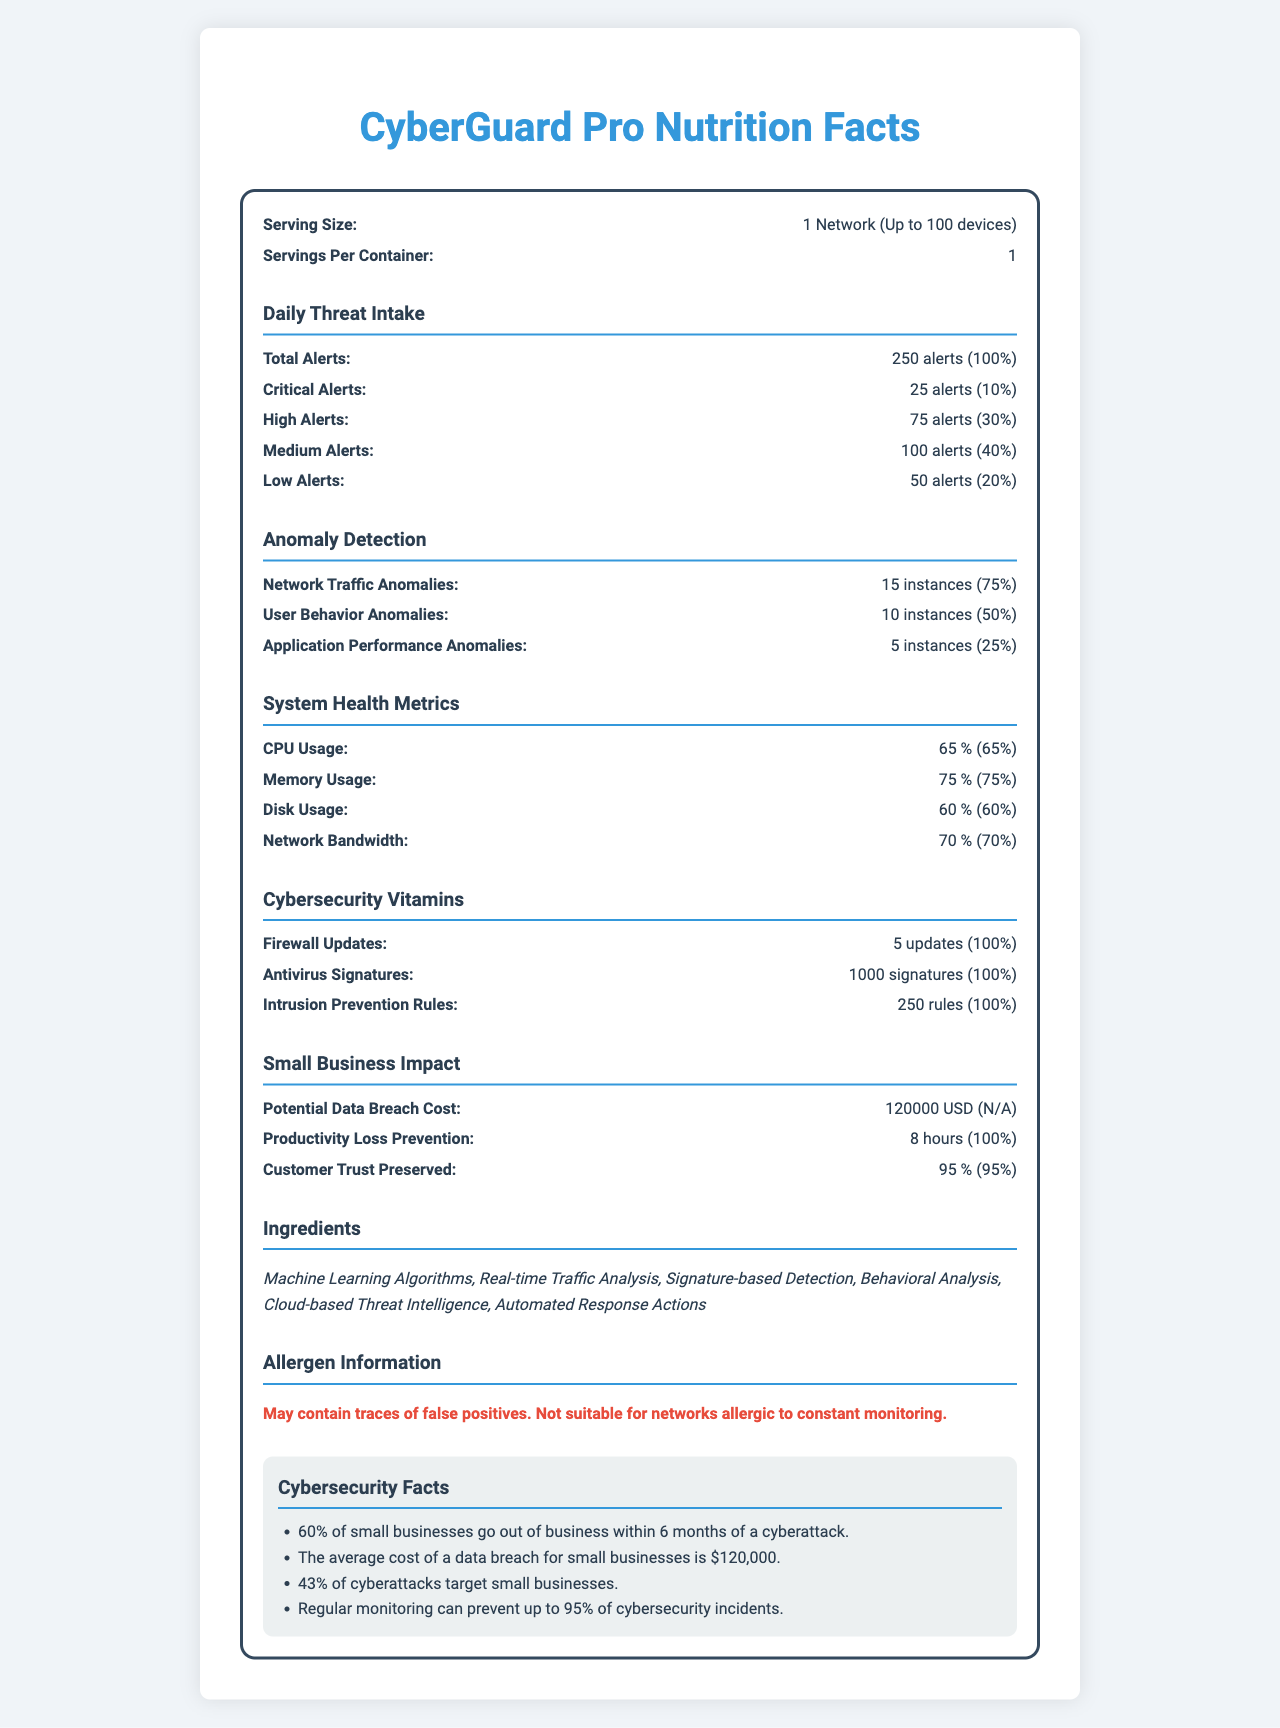what is the serving size for CyberGuard Pro? The document specifies the serving size as "1 Network (Up to 100 devices)."
Answer: 1 Network (Up to 100 devices) how many critical alerts are generated daily? The document states that the daily amount of critical alerts is 25 alerts.
Answer: 25 alerts what is the daily value percentage of high alerts? The document lists the daily value percentage of high alerts as 30%.
Answer: 30% which type of anomaly detection has the highest daily value percentage? The document shows Network Traffic Anomalies have the highest daily value percentage at 75%.
Answer: Network Traffic Anomalies how much memory is used daily in terms of percentage? The document states that the daily memory usage is 75%.
Answer: 75% which of the following metrics has the lowest daily value percentage in anomaly detection? A. Network Traffic Anomalies B. User Behavior Anomalies C. Application Performance Anomalies The document shows that Application Performance Anomalies have the lowest daily value percentage at 25%.
Answer: C. Application Performance Anomalies how many updates are provided for the firewall daily? The document states that there are 5 firewall updates daily.
Answer: 5 updates what is the potential cost of a data breach for small businesses? The document states the potential data breach cost for small businesses is $120,000.
Answer: $120,000 is customer trust preserved according to the document? The document states that customer trust is preserved at 95%.
Answer: Yes summarize the main points of the document. The document explains the serving size for CyberGuard Pro and breaks down various categories of daily cybersecurity metrics, including threat alerts, anomaly detection, and system health metrics. It also emphasizes the impact on small businesses, listing ingredients and allergen information, and providing key facts about the importance of cybersecurity measures.
Answer: The document provides a breakdown of the nutrition facts for CyberGuard Pro, detailing the daily intake of threat alerts, anomaly detection instances, system health metrics, cybersecurity measures, and the impact on small businesses. It highlights threat detection, system monitoring capabilities, and the importance of cybersecurity in preventing costly breaches and maintaining customer trust. how many types of alerts are listed under Daily Threat Intake? The document lists five types of alerts under Daily Threat Intake: Total Alerts, Critical Alerts, High Alerts, Medium Alerts, and Low Alerts.
Answer: 5 types what ingredients are used in CyberGuard Pro? The document lists the ingredients: Machine Learning Algorithms, Real-time Traffic Analysis, Signature-based Detection, Behavioral Analysis, Cloud-based Threat Intelligence, Automated Response Actions.
Answer: Machine Learning Algorithms, Real-time Traffic Analysis, Signature-based Detection, Behavioral Analysis, Cloud-based Threat Intelligence, Automated Response Actions what percentage of CPU usage is recorded daily? The document states that daily CPU usage is 65%.
Answer: 65% which system health metric has a daily value percentage of 70%? A. CPU Usage B. Memory Usage C. Disk Usage D. Network Bandwidth The document lists the daily value percentage of Network Bandwidth as 70%.
Answer: D. Network Bandwidth how many anomaly instances are detected in user behavior daily? The document states that there are 10 instances of user behavior anomalies detected daily.
Answer: 10 instances what is the total amount of antivirus signatures updated daily? The document states that 1000 antivirus signatures are updated daily.
Answer: 1000 signatures describe the allergen information for CyberGuard Pro. The document lists the allergen information as: "May contain traces of false positives. Not suitable for networks allergic to constant monitoring."
Answer: May contain traces of false positives. Not suitable for networks allergic to constant monitoring. how many cybersecurity facts are listed at the end of the document? The document lists four cybersecurity facts at the end.
Answer: 4 facts how often does the document suggest that small businesses experience cyberattacks? The document mentions cyberattacks but does not specify a frequency indicating how often small businesses experience them.
Answer: Not enough information 